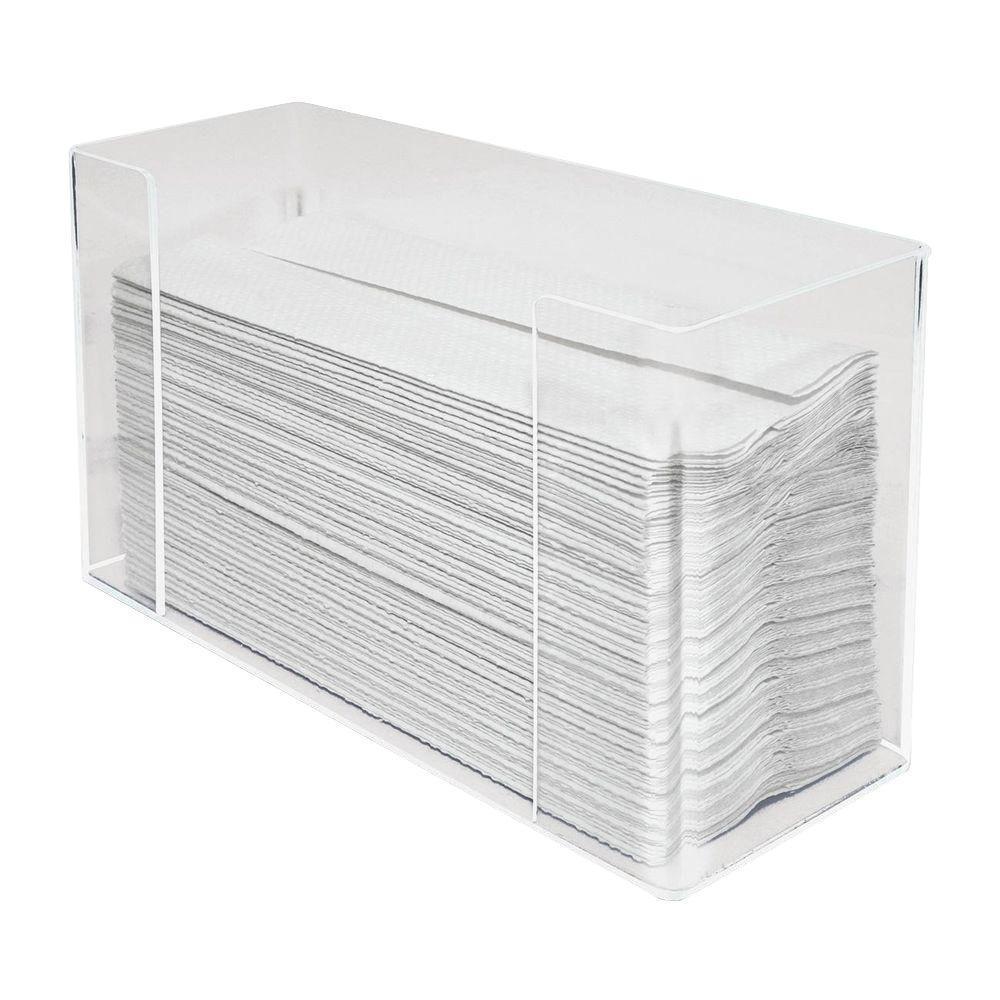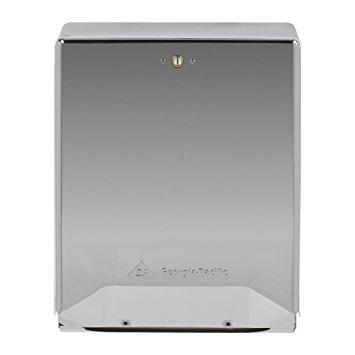The first image is the image on the left, the second image is the image on the right. Examine the images to the left and right. Is the description "There is not paper visible in the grey dispenser in the right." accurate? Answer yes or no. Yes. The first image is the image on the left, the second image is the image on the right. Considering the images on both sides, is "At least one image shows exactly one clear rectangular tray-like container of folded paper towels." valid? Answer yes or no. Yes. 